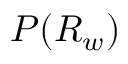Convert formula to latex. <formula><loc_0><loc_0><loc_500><loc_500>P ( R _ { w } )</formula> 